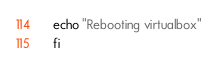Convert code to text. <code><loc_0><loc_0><loc_500><loc_500><_Bash_>echo "Rebooting virtualbox"
fi</code> 